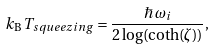<formula> <loc_0><loc_0><loc_500><loc_500>k _ { \mathrm B } \, T _ { s q u e e z i n g } = \frac { \hbar { \, } \omega _ { i } } { 2 \log ( \coth ( \zeta ) ) } ,</formula> 